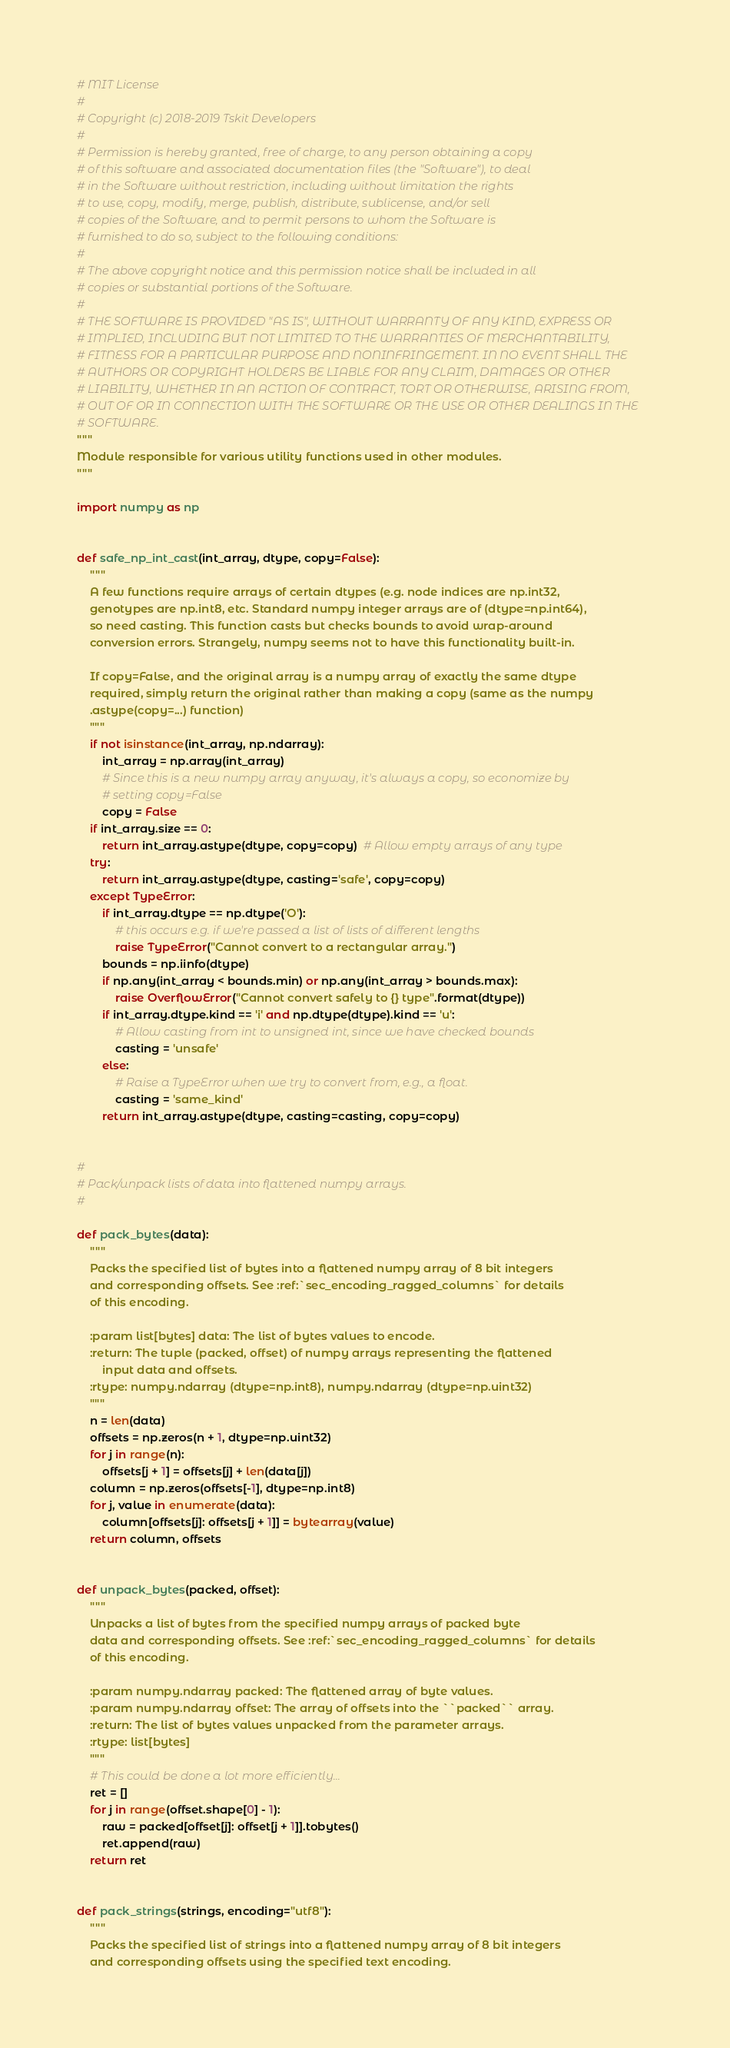<code> <loc_0><loc_0><loc_500><loc_500><_Python_># MIT License
#
# Copyright (c) 2018-2019 Tskit Developers
#
# Permission is hereby granted, free of charge, to any person obtaining a copy
# of this software and associated documentation files (the "Software"), to deal
# in the Software without restriction, including without limitation the rights
# to use, copy, modify, merge, publish, distribute, sublicense, and/or sell
# copies of the Software, and to permit persons to whom the Software is
# furnished to do so, subject to the following conditions:
#
# The above copyright notice and this permission notice shall be included in all
# copies or substantial portions of the Software.
#
# THE SOFTWARE IS PROVIDED "AS IS", WITHOUT WARRANTY OF ANY KIND, EXPRESS OR
# IMPLIED, INCLUDING BUT NOT LIMITED TO THE WARRANTIES OF MERCHANTABILITY,
# FITNESS FOR A PARTICULAR PURPOSE AND NONINFRINGEMENT. IN NO EVENT SHALL THE
# AUTHORS OR COPYRIGHT HOLDERS BE LIABLE FOR ANY CLAIM, DAMAGES OR OTHER
# LIABILITY, WHETHER IN AN ACTION OF CONTRACT, TORT OR OTHERWISE, ARISING FROM,
# OUT OF OR IN CONNECTION WITH THE SOFTWARE OR THE USE OR OTHER DEALINGS IN THE
# SOFTWARE.
"""
Module responsible for various utility functions used in other modules.
"""

import numpy as np


def safe_np_int_cast(int_array, dtype, copy=False):
    """
    A few functions require arrays of certain dtypes (e.g. node indices are np.int32,
    genotypes are np.int8, etc. Standard numpy integer arrays are of (dtype=np.int64),
    so need casting. This function casts but checks bounds to avoid wrap-around
    conversion errors. Strangely, numpy seems not to have this functionality built-in.

    If copy=False, and the original array is a numpy array of exactly the same dtype
    required, simply return the original rather than making a copy (same as the numpy
    .astype(copy=...) function)
    """
    if not isinstance(int_array, np.ndarray):
        int_array = np.array(int_array)
        # Since this is a new numpy array anyway, it's always a copy, so economize by
        # setting copy=False
        copy = False
    if int_array.size == 0:
        return int_array.astype(dtype, copy=copy)  # Allow empty arrays of any type
    try:
        return int_array.astype(dtype, casting='safe', copy=copy)
    except TypeError:
        if int_array.dtype == np.dtype('O'):
            # this occurs e.g. if we're passed a list of lists of different lengths
            raise TypeError("Cannot convert to a rectangular array.")
        bounds = np.iinfo(dtype)
        if np.any(int_array < bounds.min) or np.any(int_array > bounds.max):
            raise OverflowError("Cannot convert safely to {} type".format(dtype))
        if int_array.dtype.kind == 'i' and np.dtype(dtype).kind == 'u':
            # Allow casting from int to unsigned int, since we have checked bounds
            casting = 'unsafe'
        else:
            # Raise a TypeError when we try to convert from, e.g., a float.
            casting = 'same_kind'
        return int_array.astype(dtype, casting=casting, copy=copy)


#
# Pack/unpack lists of data into flattened numpy arrays.
#

def pack_bytes(data):
    """
    Packs the specified list of bytes into a flattened numpy array of 8 bit integers
    and corresponding offsets. See :ref:`sec_encoding_ragged_columns` for details
    of this encoding.

    :param list[bytes] data: The list of bytes values to encode.
    :return: The tuple (packed, offset) of numpy arrays representing the flattened
        input data and offsets.
    :rtype: numpy.ndarray (dtype=np.int8), numpy.ndarray (dtype=np.uint32)
    """
    n = len(data)
    offsets = np.zeros(n + 1, dtype=np.uint32)
    for j in range(n):
        offsets[j + 1] = offsets[j] + len(data[j])
    column = np.zeros(offsets[-1], dtype=np.int8)
    for j, value in enumerate(data):
        column[offsets[j]: offsets[j + 1]] = bytearray(value)
    return column, offsets


def unpack_bytes(packed, offset):
    """
    Unpacks a list of bytes from the specified numpy arrays of packed byte
    data and corresponding offsets. See :ref:`sec_encoding_ragged_columns` for details
    of this encoding.

    :param numpy.ndarray packed: The flattened array of byte values.
    :param numpy.ndarray offset: The array of offsets into the ``packed`` array.
    :return: The list of bytes values unpacked from the parameter arrays.
    :rtype: list[bytes]
    """
    # This could be done a lot more efficiently...
    ret = []
    for j in range(offset.shape[0] - 1):
        raw = packed[offset[j]: offset[j + 1]].tobytes()
        ret.append(raw)
    return ret


def pack_strings(strings, encoding="utf8"):
    """
    Packs the specified list of strings into a flattened numpy array of 8 bit integers
    and corresponding offsets using the specified text encoding.</code> 